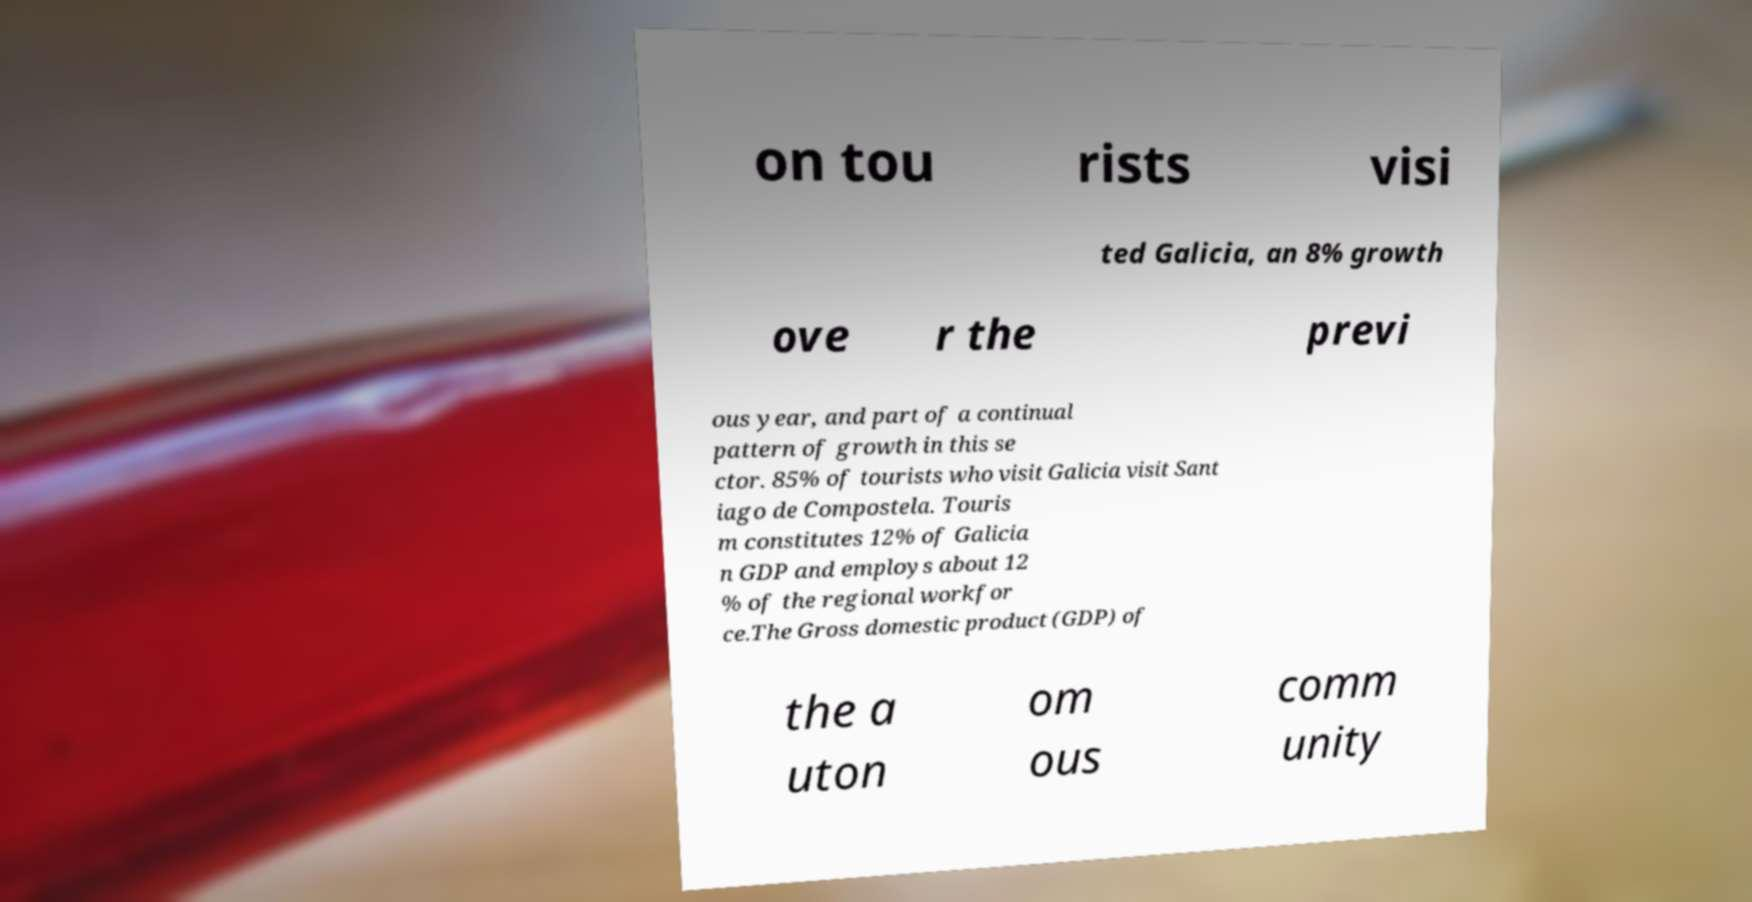Can you accurately transcribe the text from the provided image for me? on tou rists visi ted Galicia, an 8% growth ove r the previ ous year, and part of a continual pattern of growth in this se ctor. 85% of tourists who visit Galicia visit Sant iago de Compostela. Touris m constitutes 12% of Galicia n GDP and employs about 12 % of the regional workfor ce.The Gross domestic product (GDP) of the a uton om ous comm unity 